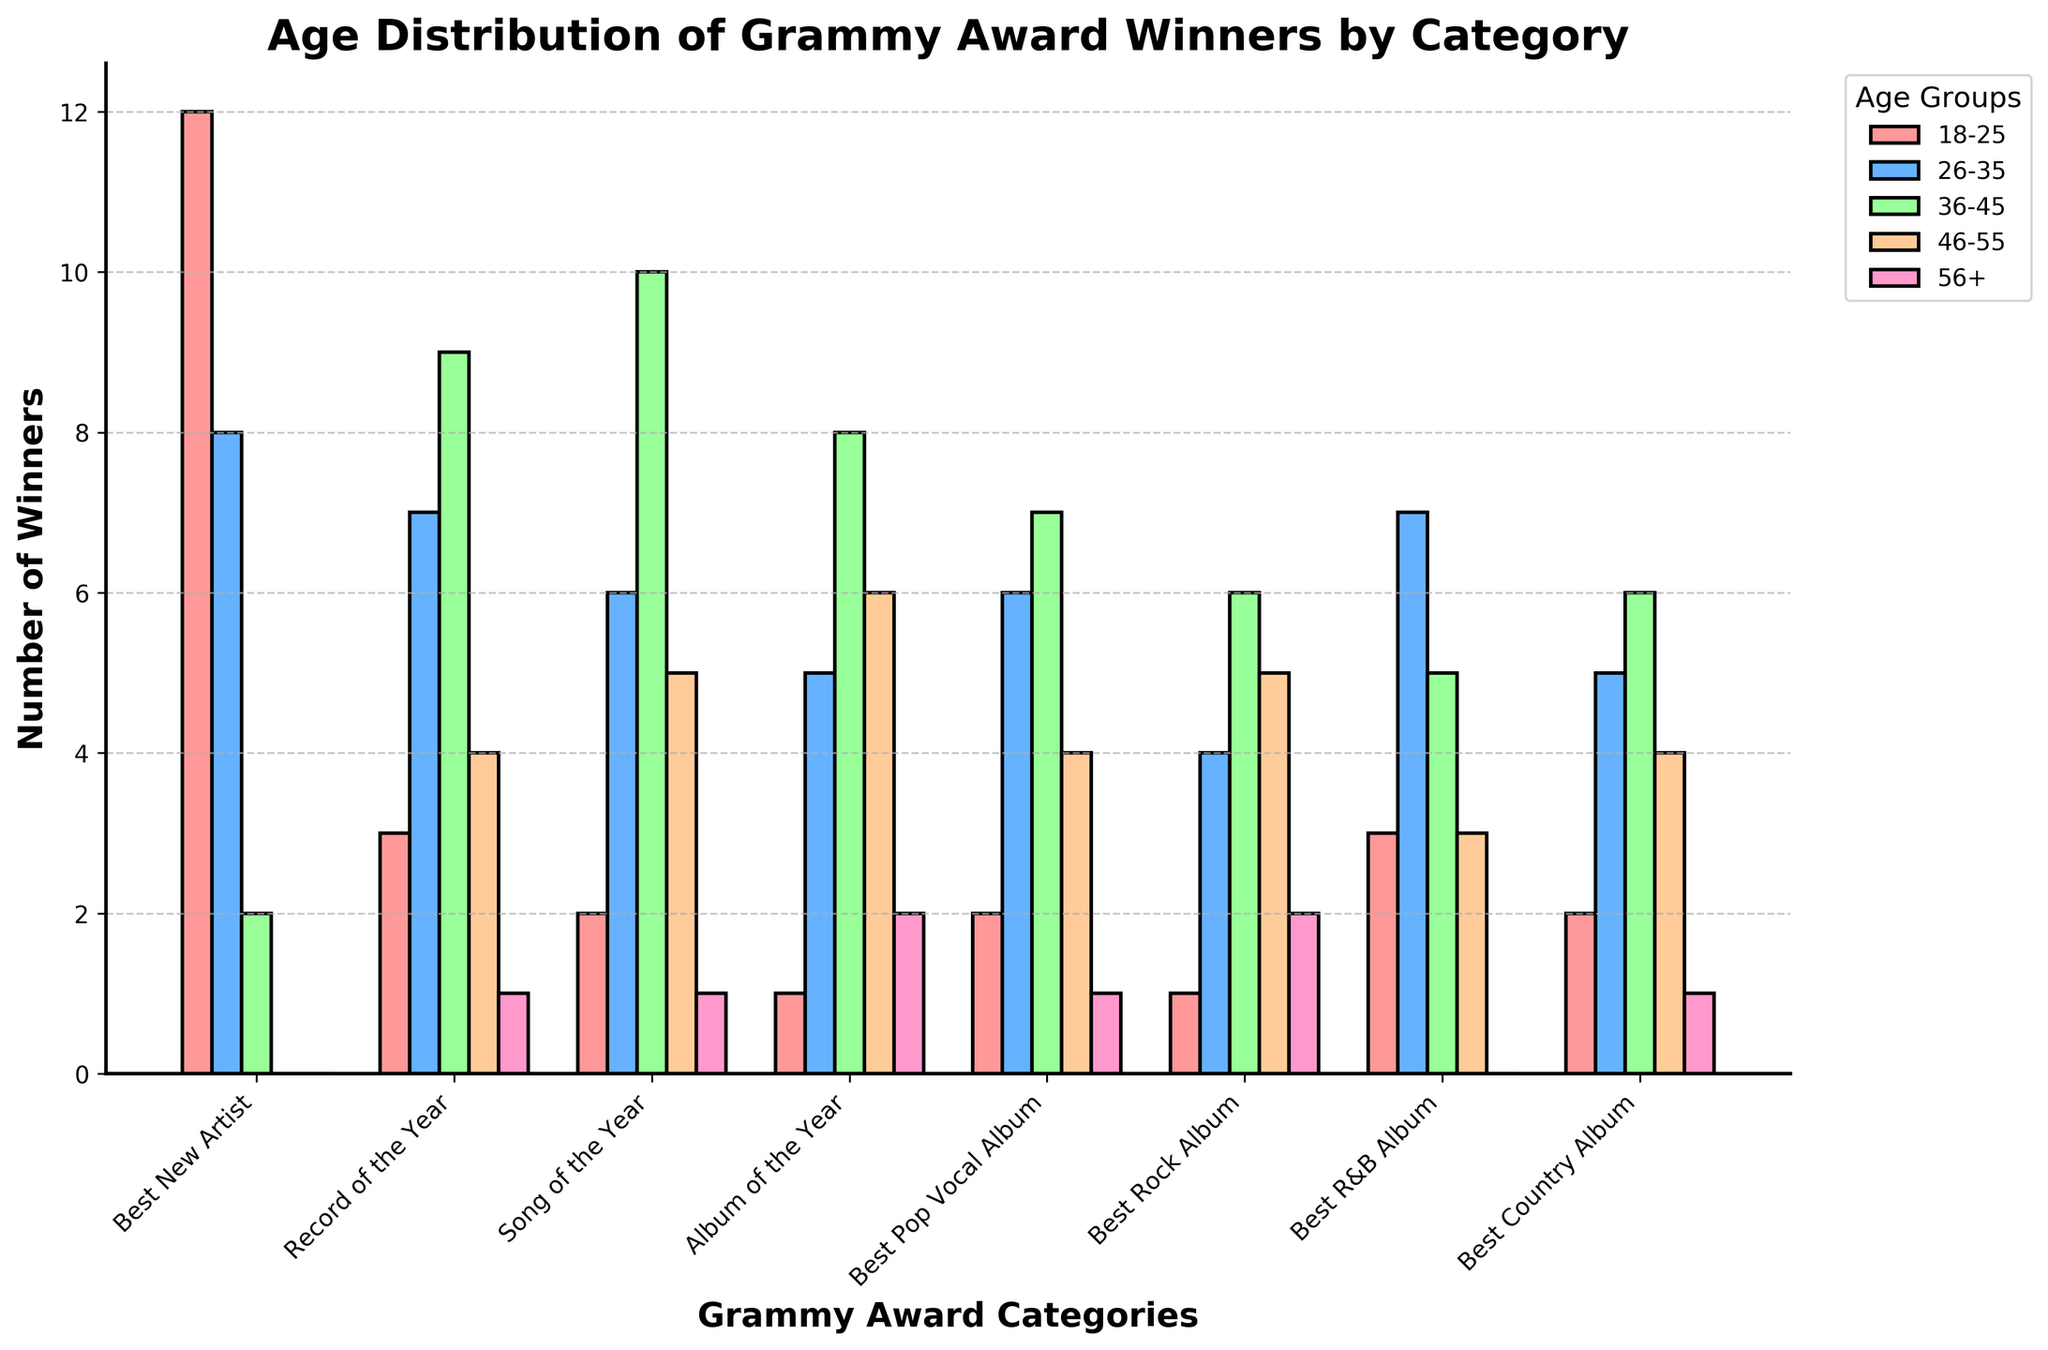What's the title of the plot? The title of the plot is displayed at the top center of the figure. It summarizes the main message of the plot.
Answer: Age Distribution of Grammy Award Winners by Category Which age group has the highest number of winners in the 'Best New Artist' category? In the 'Best New Artist' category, the bar with the highest value corresponds to the '18-25' age group.
Answer: 18-25 Among the 'Best Rock Album' winners, how many are aged 46-55? To find the number of 'Best Rock Album' winners aged 46-55, locate the bar corresponding to this age group in the 'Best Rock Album' category.
Answer: 5 Between 'Best R&B Album' and 'Best Country Album', which category has more winners aged 26-35? Compare the heights of the bars for the '26-35' age group in the 'Best R&B Album' and 'Best Country Album' categories.
Answer: Best R&B Album What is the total count of winners aged 56+ across all categories? Add the counts of the winners aged 56+ from each category: 0 (Best New Artist) + 1 (Record of the Year) + 1 (Song of the Year) + 2 (Album of the Year) + 1 (Best Pop Vocal Album) + 2 (Best Rock Album) + 0 (Best R&B Album) + 1 (Best Country Album).
Answer: 8 In which category is the age group 36-45 most dominant? Identify the category where the bar for the 36-45 age group is the highest relative to the other age groups within that category.
Answer: Song of the Year What is the combined number of winners aged 18-25 in the categories 'Record of the Year', 'Song of the Year', and 'Album of the Year'? Sum the numbers of winners aged 18-25 in the specified categories: 3 (Record of the Year) + 2 (Song of the Year) + 1 (Album of the Year).
Answer: 6 Which category has the least number of winners in the age group 46-55? Locate the category with the shortest bar for the age group 46-55 among all the categories.
Answer: Best New Artist How many more winners aged 36-45 are there in 'Song of the Year' compared to 'Best Pop Vocal Album'? Subtract the number of winners aged 36-45 in 'Best Pop Vocal Album' from those in 'Song of the Year': 10 (Song of the Year) - 7 (Best Pop Vocal Album).
Answer: 3 